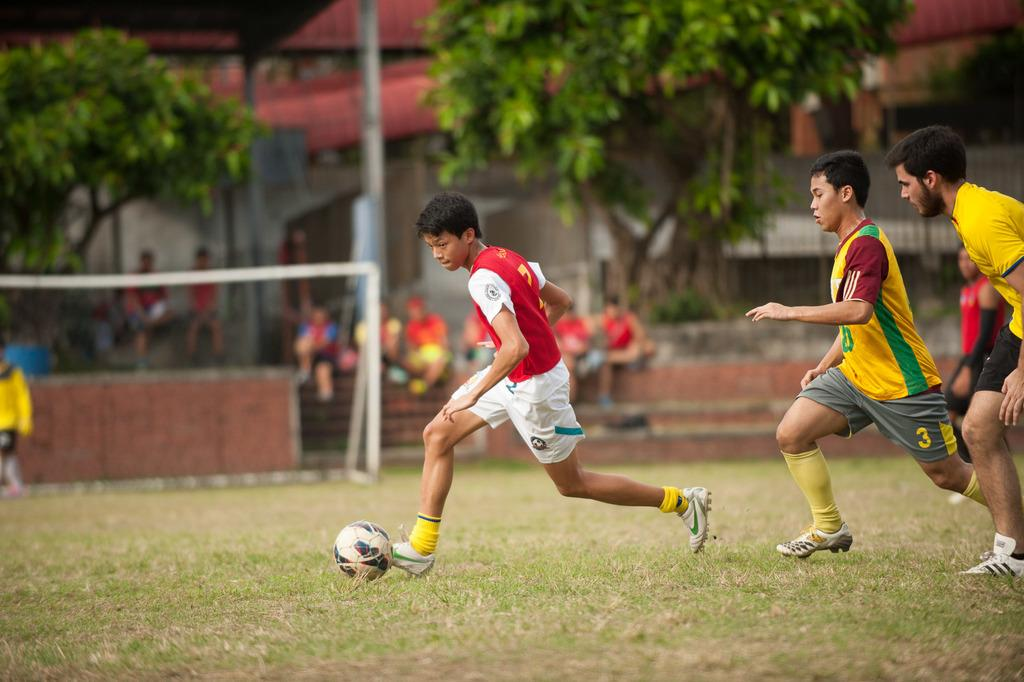Provide a one-sentence caption for the provided image. Three young men playing soccer with one man dressed in red and white kicking the ball while the other two men chase him. 